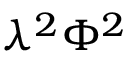<formula> <loc_0><loc_0><loc_500><loc_500>\lambda ^ { 2 } \Phi ^ { 2 }</formula> 